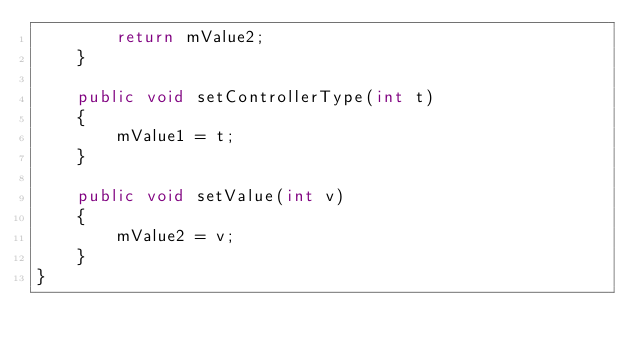<code> <loc_0><loc_0><loc_500><loc_500><_Java_>        return mValue2;
    }

    public void setControllerType(int t)
    {
        mValue1 = t;
    }

    public void setValue(int v)
    {
        mValue2 = v;
    }
}
</code> 